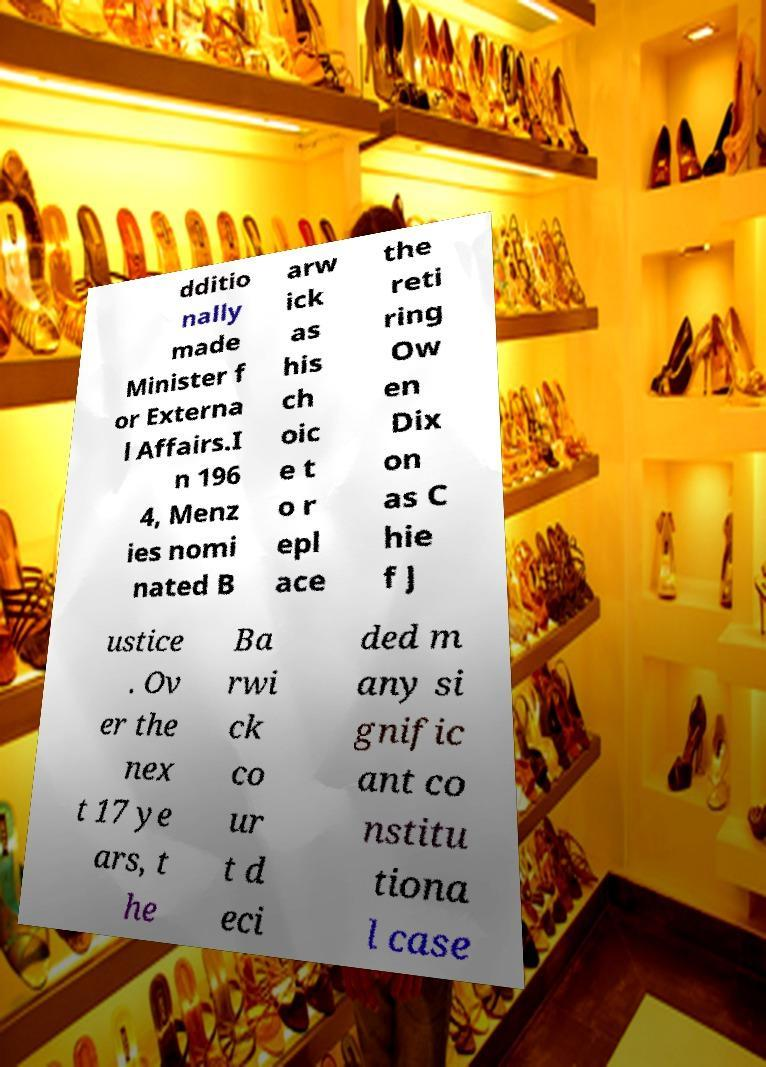Could you assist in decoding the text presented in this image and type it out clearly? dditio nally made Minister f or Externa l Affairs.I n 196 4, Menz ies nomi nated B arw ick as his ch oic e t o r epl ace the reti ring Ow en Dix on as C hie f J ustice . Ov er the nex t 17 ye ars, t he Ba rwi ck co ur t d eci ded m any si gnific ant co nstitu tiona l case 